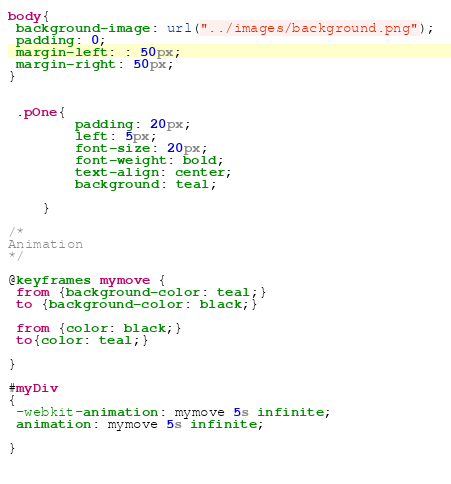Convert code to text. <code><loc_0><loc_0><loc_500><loc_500><_CSS_>
body{
 background-image: url("../images/background.png"); 
 padding: 0;
 margin-left: : 50px;
 margin-right: 50px;
}


 .pOne{
        padding: 20px;
        left: 5px;
        font-size: 20px;
        font-weight: bold;
        text-align: center;
        background: teal;
        
    }

/* 
Animation 
*/

@keyframes mymove {
 from {background-color: teal;}
 to {background-color: black;}

 from {color: black;}
 to{color: teal;}

}

#myDiv
{
 -webkit-animation: mymove 5s infinite;
 animation: mymove 5s infinite;
 	
}

   </code> 